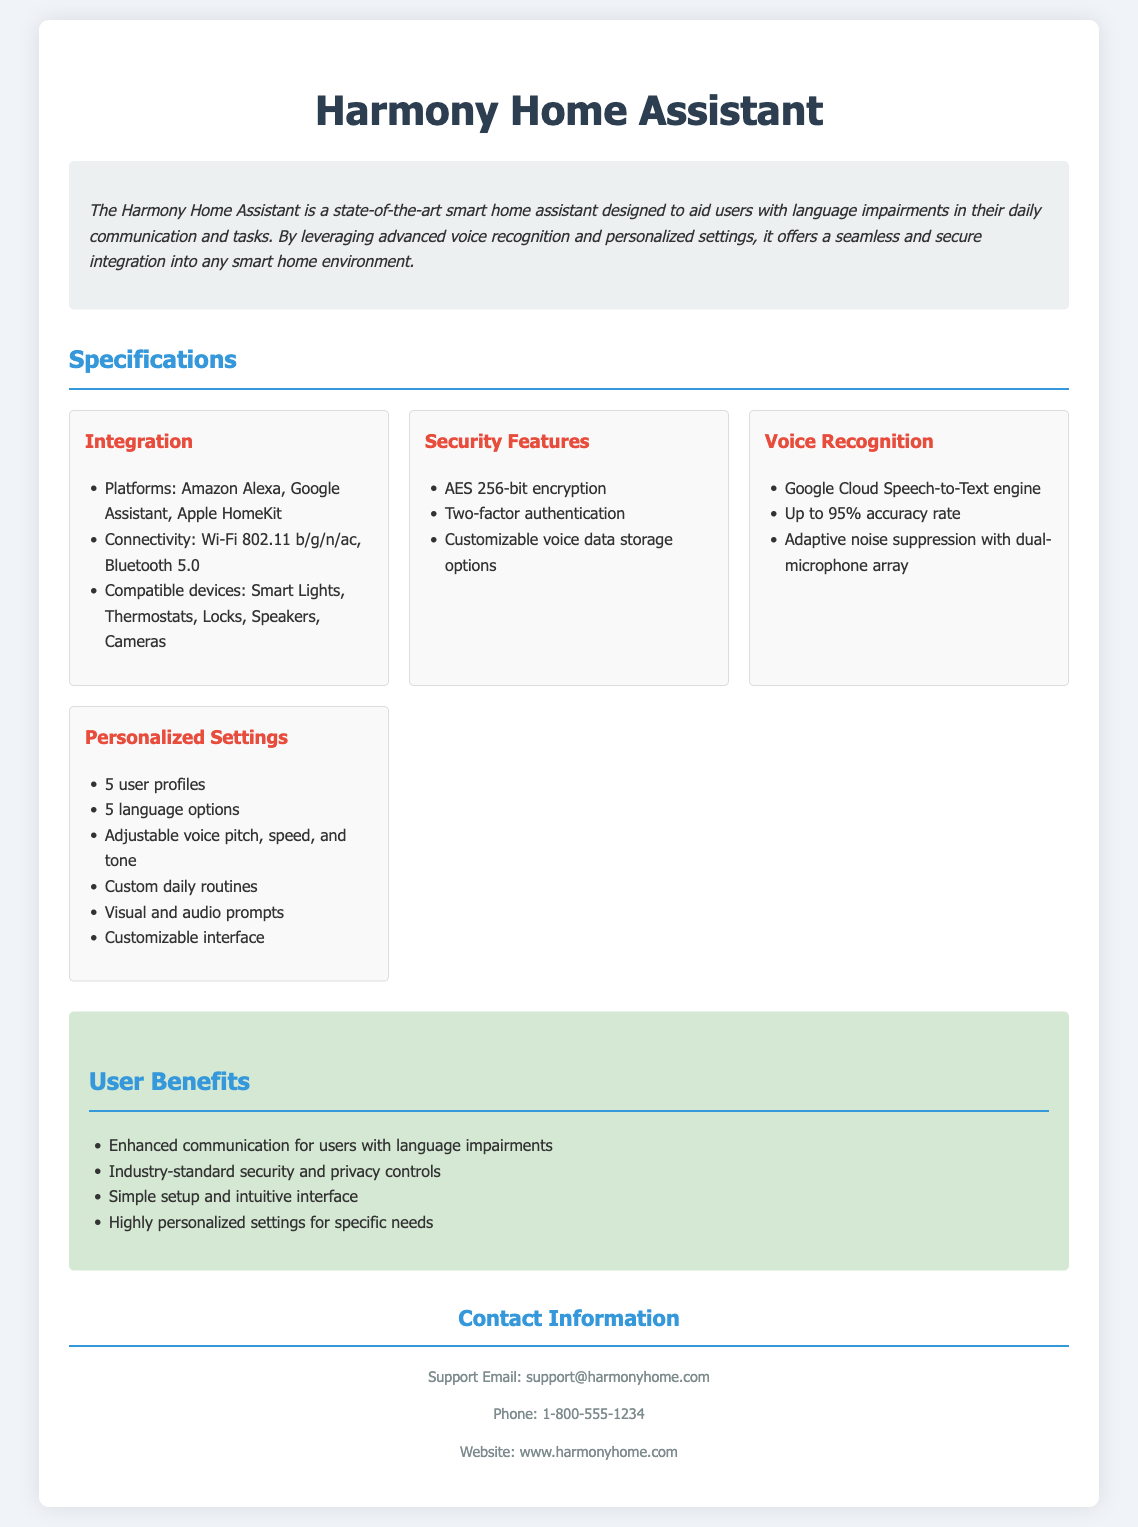what platforms does the Harmony Home Assistant integrate with? The platforms listed for integration in the document are Amazon Alexa, Google Assistant, and Apple HomeKit.
Answer: Amazon Alexa, Google Assistant, Apple HomeKit what is the accuracy rate of the voice recognition? The accuracy rate for voice recognition is mentioned as up to 95%.
Answer: 95% how many user profiles can be set in the personalized settings? The document states that up to 5 user profiles can be set.
Answer: 5 user profiles what type of encryption is used for security features? The document specifies that AES 256-bit encryption is used.
Answer: AES 256-bit encryption what is the primary technology used for voice recognition in the Harmony Home Assistant? The document identifies the Google Cloud Speech-to-Text engine as the primary technology.
Answer: Google Cloud Speech-to-Text engine how many language options are available for personalized settings? According to the document, there are 5 language options available.
Answer: 5 language options what customizable feature is listed for daily routines? The document mentions "Custom daily routines" as a customizable feature.
Answer: Custom daily routines which feature helps with noise interference during voice recognition? The document states that adaptive noise suppression with dual-microphone array helps with noise interference.
Answer: Adaptive noise suppression with dual-microphone array what type of authentication is included in the security features? The document indicates that two-factor authentication is included.
Answer: Two-factor authentication 